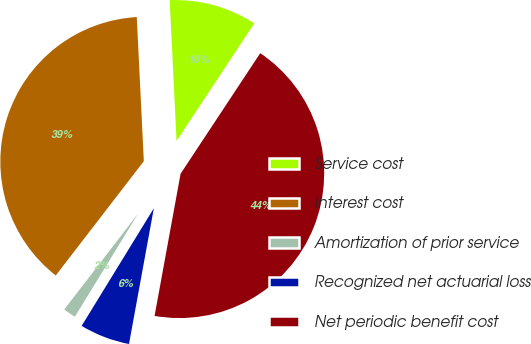Convert chart to OTSL. <chart><loc_0><loc_0><loc_500><loc_500><pie_chart><fcel>Service cost<fcel>Interest cost<fcel>Amortization of prior service<fcel>Recognized net actuarial loss<fcel>Net periodic benefit cost<nl><fcel>10.07%<fcel>38.77%<fcel>1.69%<fcel>5.88%<fcel>43.59%<nl></chart> 